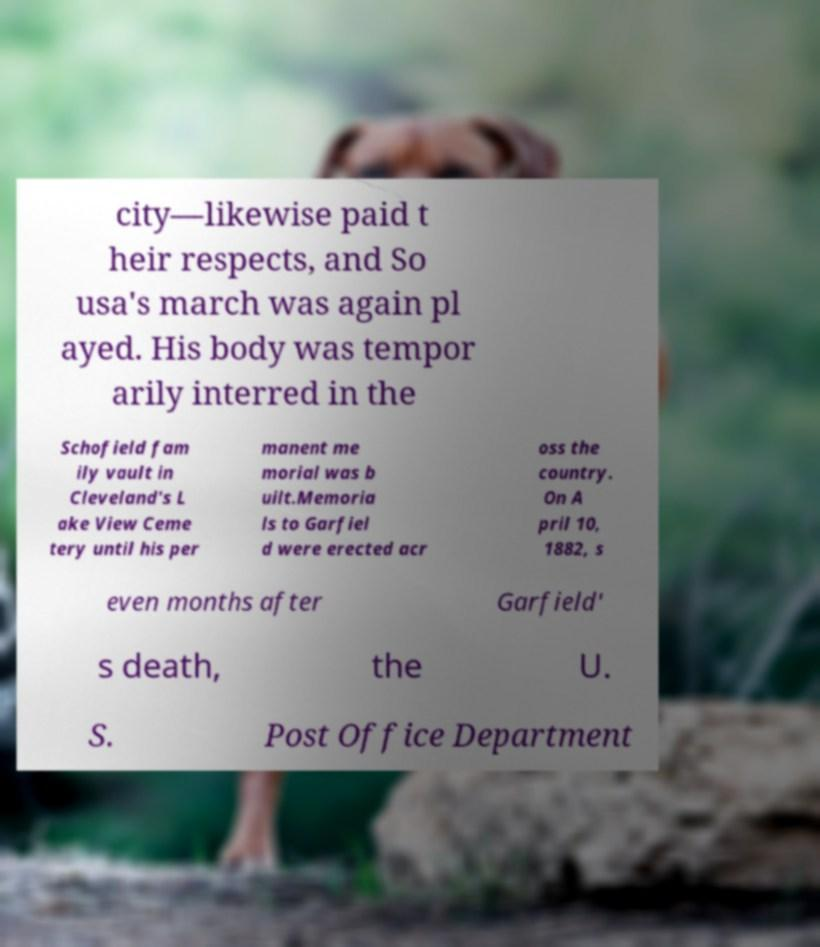There's text embedded in this image that I need extracted. Can you transcribe it verbatim? city—likewise paid t heir respects, and So usa's march was again pl ayed. His body was tempor arily interred in the Schofield fam ily vault in Cleveland's L ake View Ceme tery until his per manent me morial was b uilt.Memoria ls to Garfiel d were erected acr oss the country. On A pril 10, 1882, s even months after Garfield' s death, the U. S. Post Office Department 